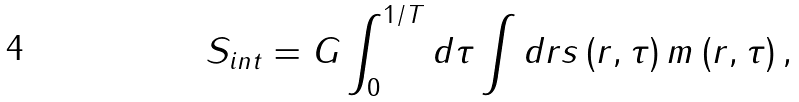Convert formula to latex. <formula><loc_0><loc_0><loc_500><loc_500>S _ { i n t } = G \int _ { 0 } ^ { 1 / T } d \tau \int d r s \left ( r , \tau \right ) m \left ( r , \tau \right ) ,</formula> 